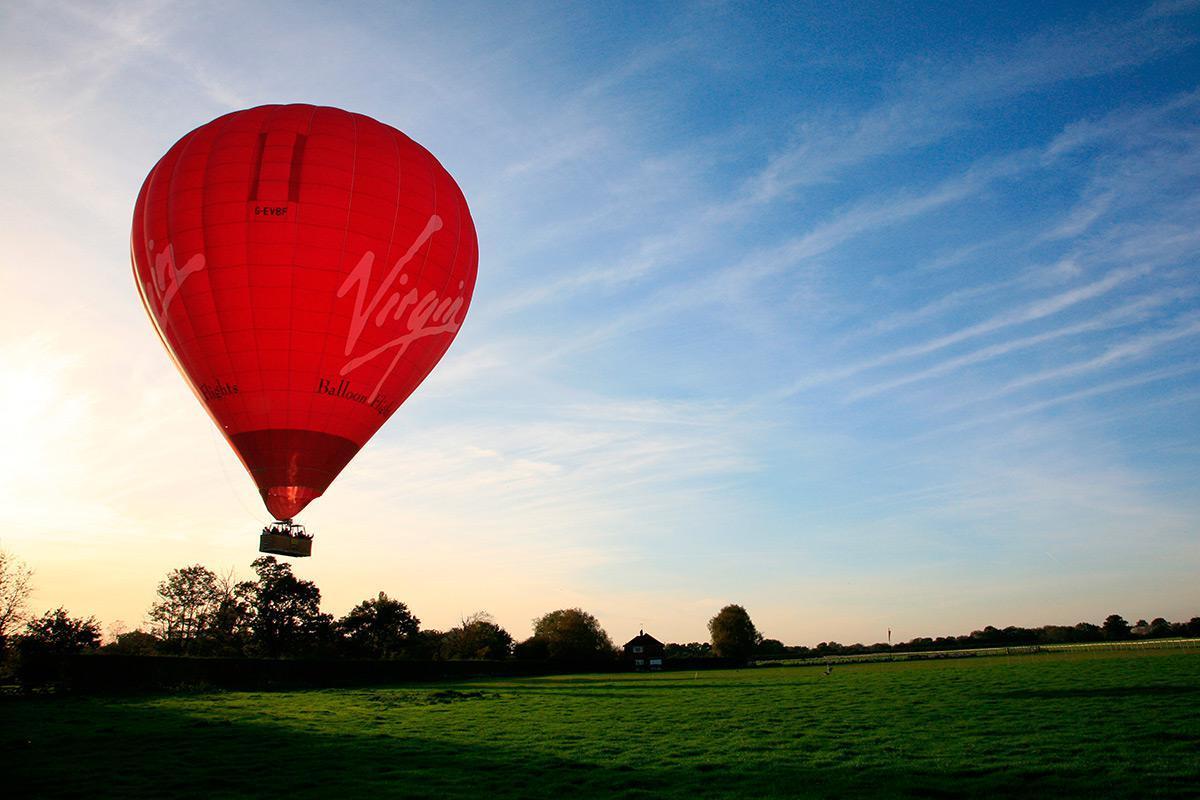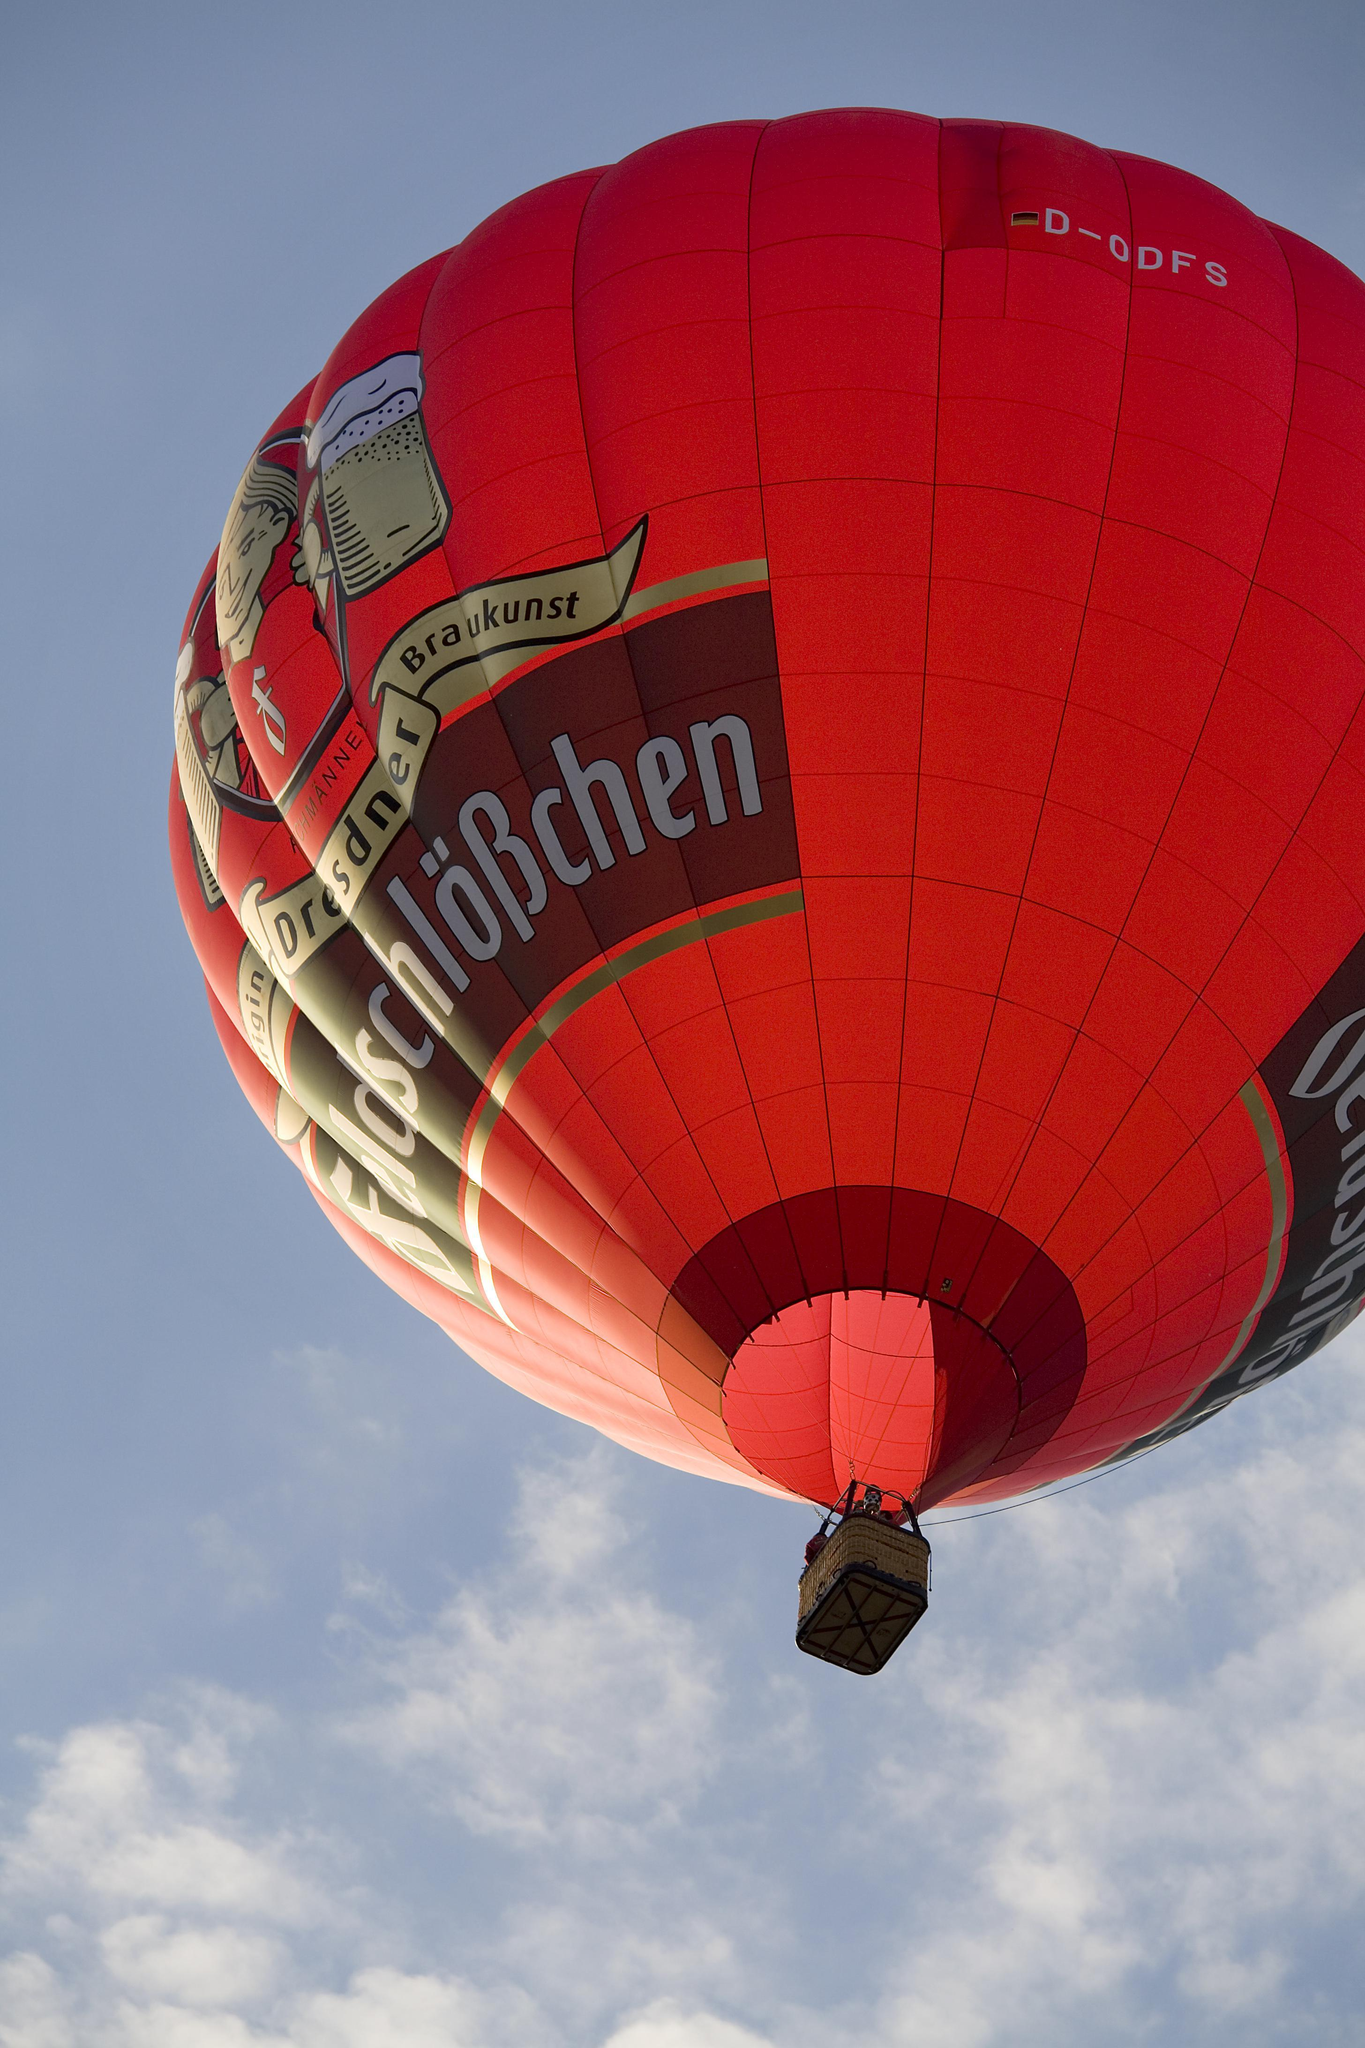The first image is the image on the left, the second image is the image on the right. Evaluate the accuracy of this statement regarding the images: "Two hot air balloons are predominantly red and have baskets for passengers.". Is it true? Answer yes or no. Yes. 